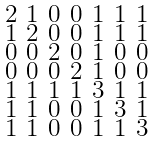<formula> <loc_0><loc_0><loc_500><loc_500>\begin{smallmatrix} 2 & 1 & 0 & 0 & 1 & 1 & 1 \\ 1 & 2 & 0 & 0 & 1 & 1 & 1 \\ 0 & 0 & 2 & 0 & 1 & 0 & 0 \\ 0 & 0 & 0 & 2 & 1 & 0 & 0 \\ 1 & 1 & 1 & 1 & 3 & 1 & 1 \\ 1 & 1 & 0 & 0 & 1 & 3 & 1 \\ 1 & 1 & 0 & 0 & 1 & 1 & 3 \end{smallmatrix}</formula> 